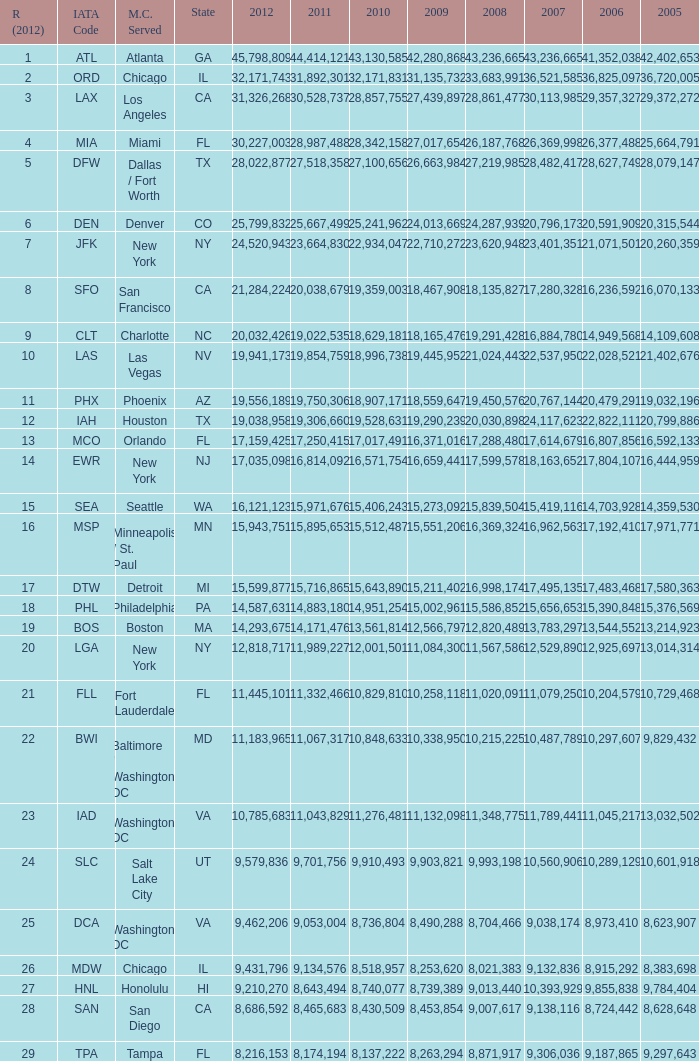For the IATA code of lax with 2009 less than 31,135,732 and 2011 less than 8,174,194, what is the sum of 2012? 0.0. 